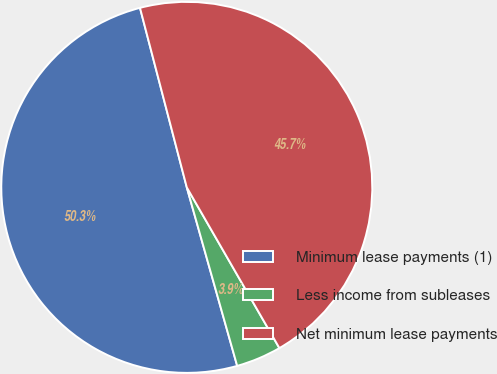Convert chart. <chart><loc_0><loc_0><loc_500><loc_500><pie_chart><fcel>Minimum lease payments (1)<fcel>Less income from subleases<fcel>Net minimum lease payments<nl><fcel>50.32%<fcel>3.94%<fcel>45.74%<nl></chart> 